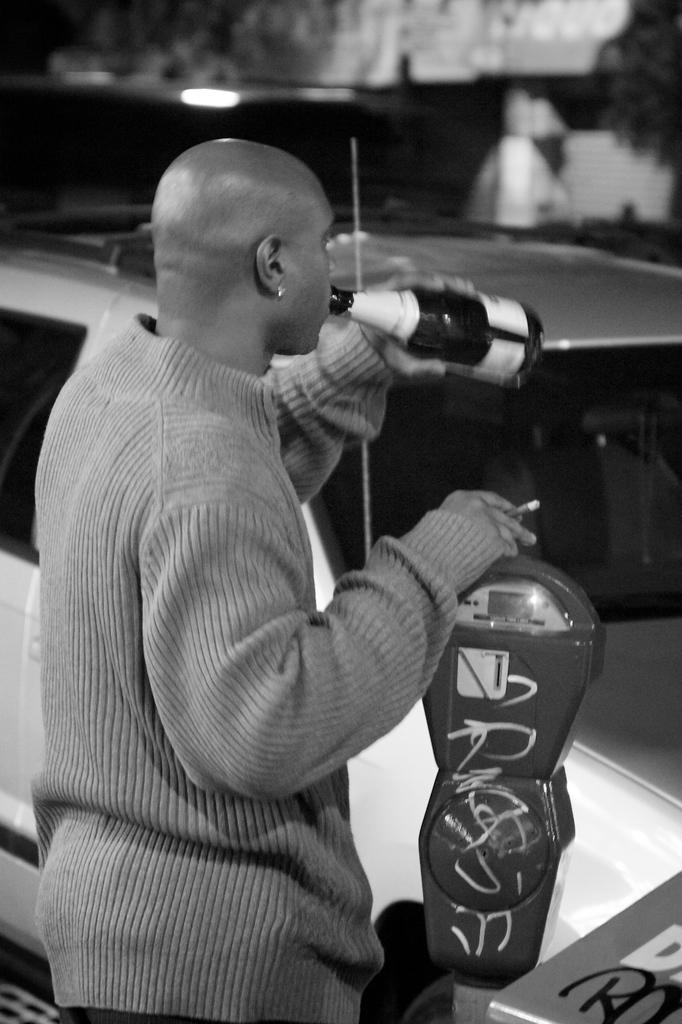Please provide a concise description of this image. It is a black and white picture where one person is standing and drinking and holding a cigarette in other hand in front of him there is a vehicle. 